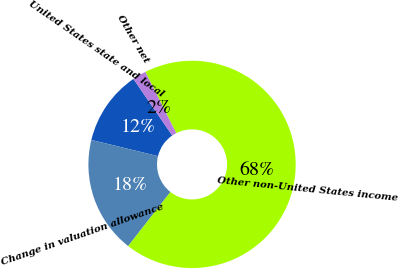<chart> <loc_0><loc_0><loc_500><loc_500><pie_chart><fcel>United States state and local<fcel>Change in valuation allowance<fcel>Other non-United States income<fcel>Other net<nl><fcel>11.64%<fcel>18.23%<fcel>68.0%<fcel>2.12%<nl></chart> 